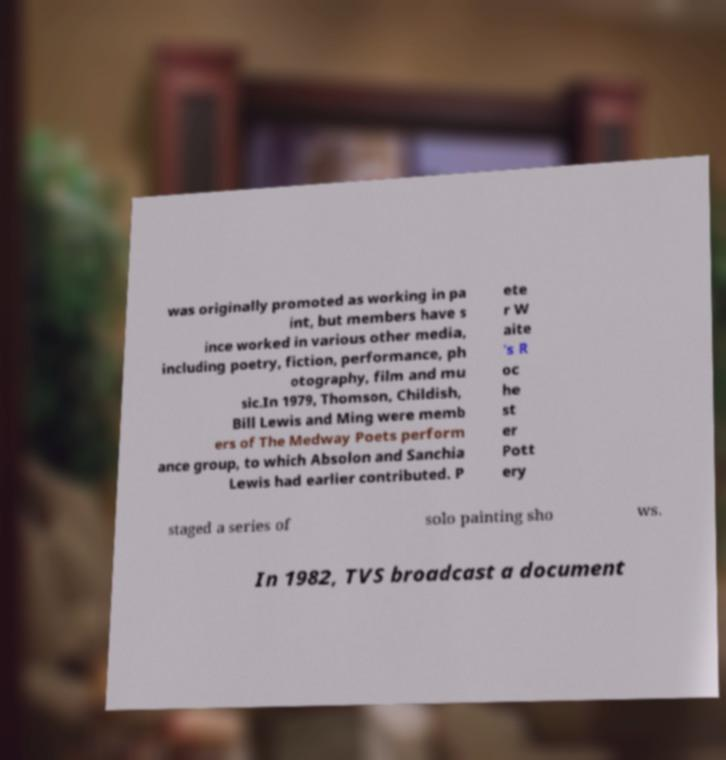Can you accurately transcribe the text from the provided image for me? was originally promoted as working in pa int, but members have s ince worked in various other media, including poetry, fiction, performance, ph otography, film and mu sic.In 1979, Thomson, Childish, Bill Lewis and Ming were memb ers of The Medway Poets perform ance group, to which Absolon and Sanchia Lewis had earlier contributed. P ete r W aite 's R oc he st er Pott ery staged a series of solo painting sho ws. In 1982, TVS broadcast a document 